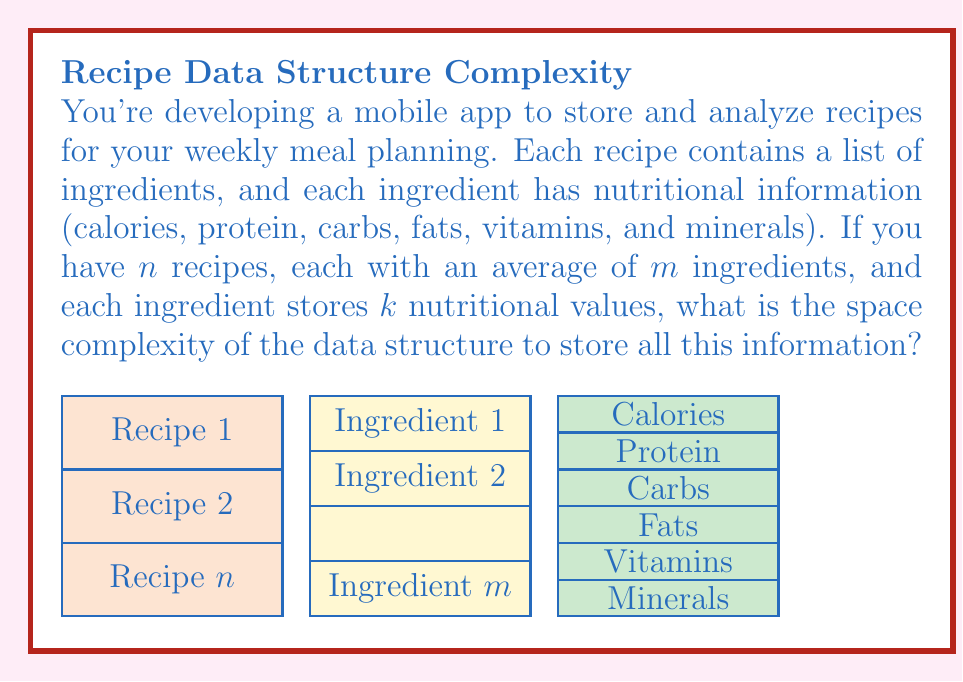Solve this math problem. Let's break down the space complexity analysis step by step:

1) We have $n$ recipes in total.

2) Each recipe contains, on average, $m$ ingredients.

3) For each ingredient, we store $k$ nutritional values.

4) The space required for each nutritional value is constant, let's call it $c$.

5) For each ingredient, we need space for $k$ nutritional values:
   $$ \text{Space per ingredient} = k \cdot c $$

6) Each recipe has $m$ ingredients, so the space for one recipe is:
   $$ \text{Space per recipe} = m \cdot (k \cdot c) = m \cdot k \cdot c $$

7) We have $n$ recipes in total, so the total space required is:
   $$ \text{Total space} = n \cdot (m \cdot k \cdot c) = n \cdot m \cdot k \cdot c $$

8) In Big O notation, we drop constant factors. Here, $c$ is a constant, so we can remove it:
   $$ O(n \cdot m \cdot k) $$

9) If $m$ and $k$ are considered constants (i.e., the number of ingredients per recipe and the number of nutritional values per ingredient don't grow with the input size), we can simplify further to:
   $$ O(n) $$

However, if $m$ and $k$ can vary with the input size, we keep the full expression $O(n \cdot m \cdot k)$.
Answer: $O(n \cdot m \cdot k)$ 